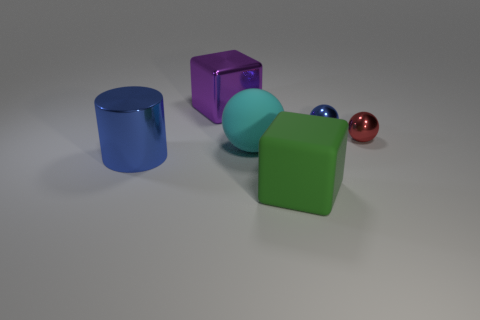How many things are metal balls or large matte objects that are on the left side of the big rubber block?
Provide a short and direct response. 3. How many other things are there of the same color as the matte ball?
Give a very brief answer. 0. Do the cylinder and the blue shiny object on the right side of the large green block have the same size?
Offer a terse response. No. There is a sphere behind the red shiny thing; does it have the same size as the small red sphere?
Your answer should be very brief. Yes. What number of other objects are the same material as the big purple object?
Your answer should be very brief. 3. Is the number of spheres that are behind the cylinder the same as the number of big cylinders to the left of the blue metal sphere?
Ensure brevity in your answer.  No. What color is the big block in front of the sphere on the left side of the block right of the large purple shiny thing?
Offer a very short reply. Green. There is a blue thing that is on the right side of the big metal cylinder; what is its shape?
Keep it short and to the point. Sphere. What shape is the tiny blue thing that is the same material as the red thing?
Your answer should be very brief. Sphere. Is there any other thing that has the same shape as the big green rubber object?
Your answer should be very brief. Yes. 